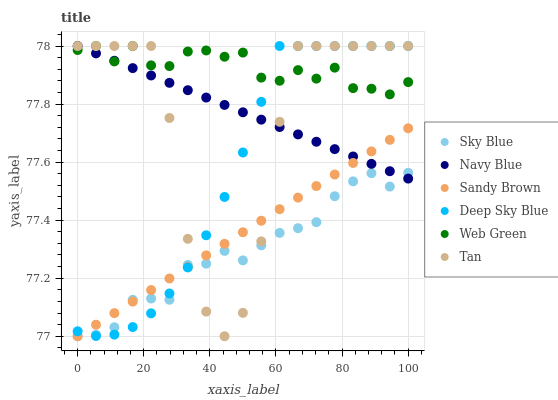Does Sky Blue have the minimum area under the curve?
Answer yes or no. Yes. Does Web Green have the maximum area under the curve?
Answer yes or no. Yes. Does Deep Sky Blue have the minimum area under the curve?
Answer yes or no. No. Does Deep Sky Blue have the maximum area under the curve?
Answer yes or no. No. Is Navy Blue the smoothest?
Answer yes or no. Yes. Is Tan the roughest?
Answer yes or no. Yes. Is Web Green the smoothest?
Answer yes or no. No. Is Web Green the roughest?
Answer yes or no. No. Does Sky Blue have the lowest value?
Answer yes or no. Yes. Does Deep Sky Blue have the lowest value?
Answer yes or no. No. Does Tan have the highest value?
Answer yes or no. Yes. Does Sky Blue have the highest value?
Answer yes or no. No. Is Sandy Brown less than Web Green?
Answer yes or no. Yes. Is Web Green greater than Sandy Brown?
Answer yes or no. Yes. Does Tan intersect Sky Blue?
Answer yes or no. Yes. Is Tan less than Sky Blue?
Answer yes or no. No. Is Tan greater than Sky Blue?
Answer yes or no. No. Does Sandy Brown intersect Web Green?
Answer yes or no. No. 